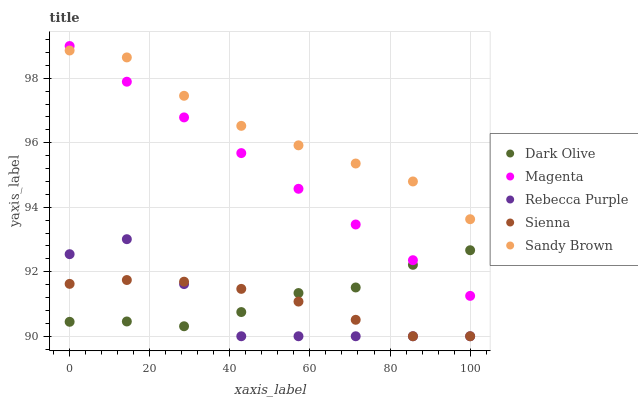Does Rebecca Purple have the minimum area under the curve?
Answer yes or no. Yes. Does Sandy Brown have the maximum area under the curve?
Answer yes or no. Yes. Does Magenta have the minimum area under the curve?
Answer yes or no. No. Does Magenta have the maximum area under the curve?
Answer yes or no. No. Is Magenta the smoothest?
Answer yes or no. Yes. Is Rebecca Purple the roughest?
Answer yes or no. Yes. Is Dark Olive the smoothest?
Answer yes or no. No. Is Dark Olive the roughest?
Answer yes or no. No. Does Sienna have the lowest value?
Answer yes or no. Yes. Does Magenta have the lowest value?
Answer yes or no. No. Does Magenta have the highest value?
Answer yes or no. Yes. Does Dark Olive have the highest value?
Answer yes or no. No. Is Dark Olive less than Sandy Brown?
Answer yes or no. Yes. Is Sandy Brown greater than Rebecca Purple?
Answer yes or no. Yes. Does Magenta intersect Dark Olive?
Answer yes or no. Yes. Is Magenta less than Dark Olive?
Answer yes or no. No. Is Magenta greater than Dark Olive?
Answer yes or no. No. Does Dark Olive intersect Sandy Brown?
Answer yes or no. No. 